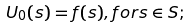Convert formula to latex. <formula><loc_0><loc_0><loc_500><loc_500>U _ { 0 } ( s ) = f ( s ) , f o r s \in S ;</formula> 